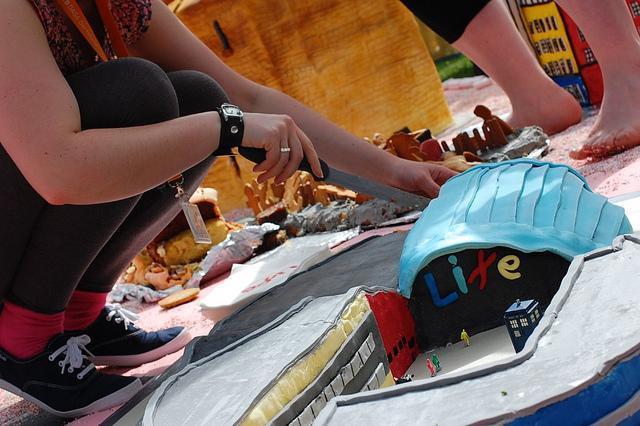How many people are in the photo?
Give a very brief answer. 2. 